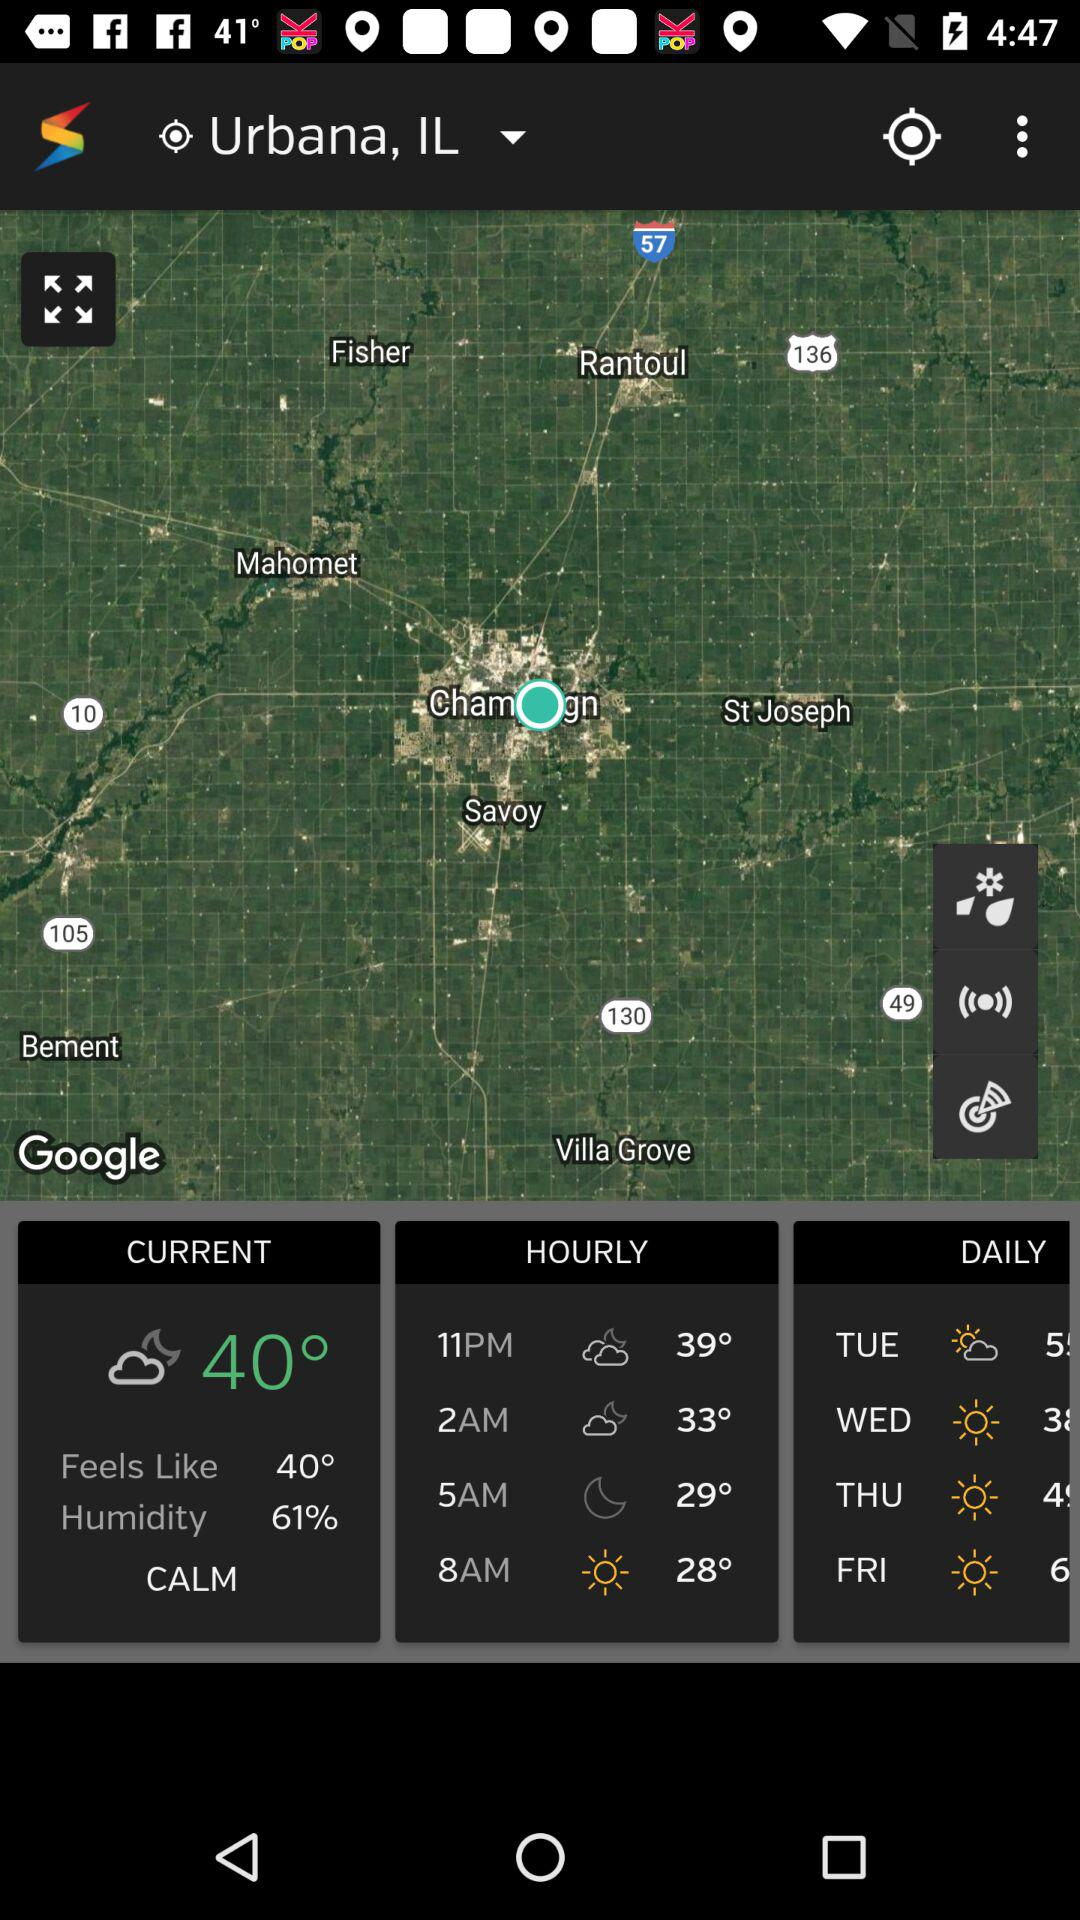What was the temperature at 8:00 AM? The temperature at 8 a.m. was 28°. 